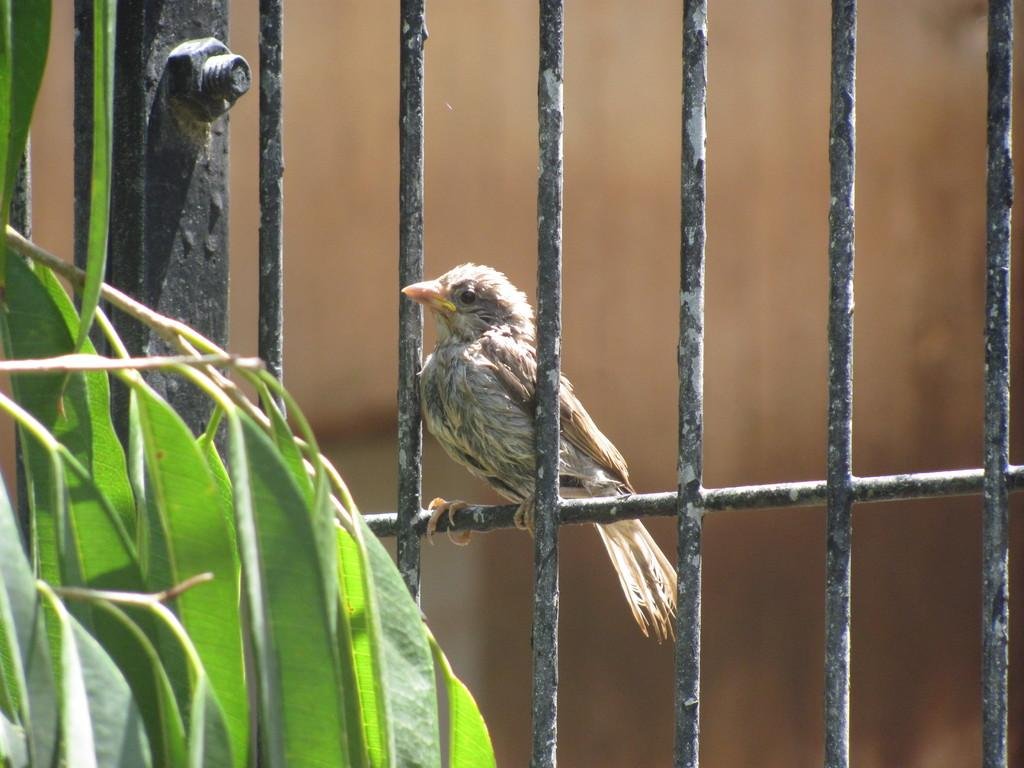What can be seen on the railing in the image? A bird is present on the railing in the image. What type of vegetation is visible on the left side of the image? There are leaves on the left side of the image. How would you describe the background of the image? The background of the image is blurred. Can you see any salt on the railing in the image? There is no salt present on the railing in the image. Is there a recess visible in the image? There is no recess present in the image. 